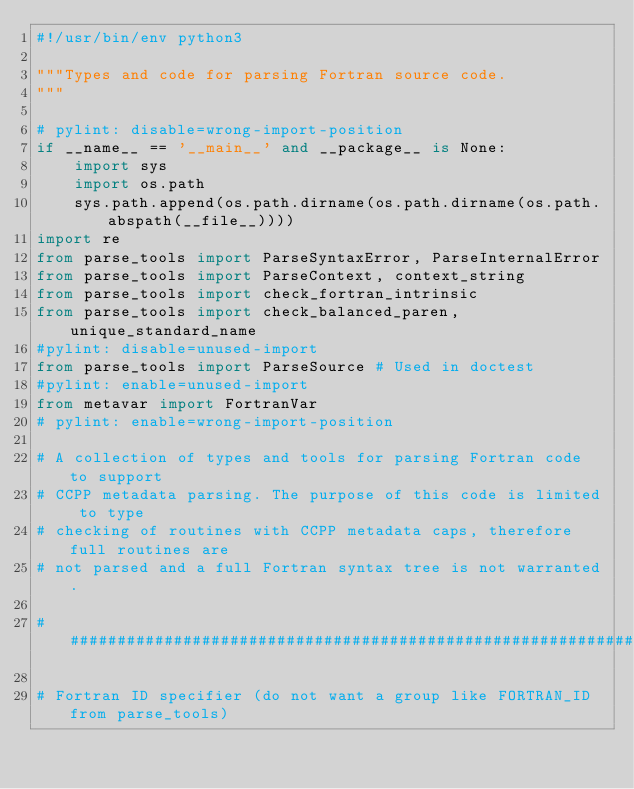<code> <loc_0><loc_0><loc_500><loc_500><_Python_>#!/usr/bin/env python3

"""Types and code for parsing Fortran source code.
"""

# pylint: disable=wrong-import-position
if __name__ == '__main__' and __package__ is None:
    import sys
    import os.path
    sys.path.append(os.path.dirname(os.path.dirname(os.path.abspath(__file__))))
import re
from parse_tools import ParseSyntaxError, ParseInternalError
from parse_tools import ParseContext, context_string
from parse_tools import check_fortran_intrinsic
from parse_tools import check_balanced_paren, unique_standard_name
#pylint: disable=unused-import
from parse_tools import ParseSource # Used in doctest
#pylint: enable=unused-import
from metavar import FortranVar
# pylint: enable=wrong-import-position

# A collection of types and tools for parsing Fortran code to support
# CCPP metadata parsing. The purpose of this code is limited to type
# checking of routines with CCPP metadata caps, therefore full routines are
# not parsed and a full Fortran syntax tree is not warranted.

########################################################################

# Fortran ID specifier (do not want a group like FORTRAN_ID from parse_tools)</code> 